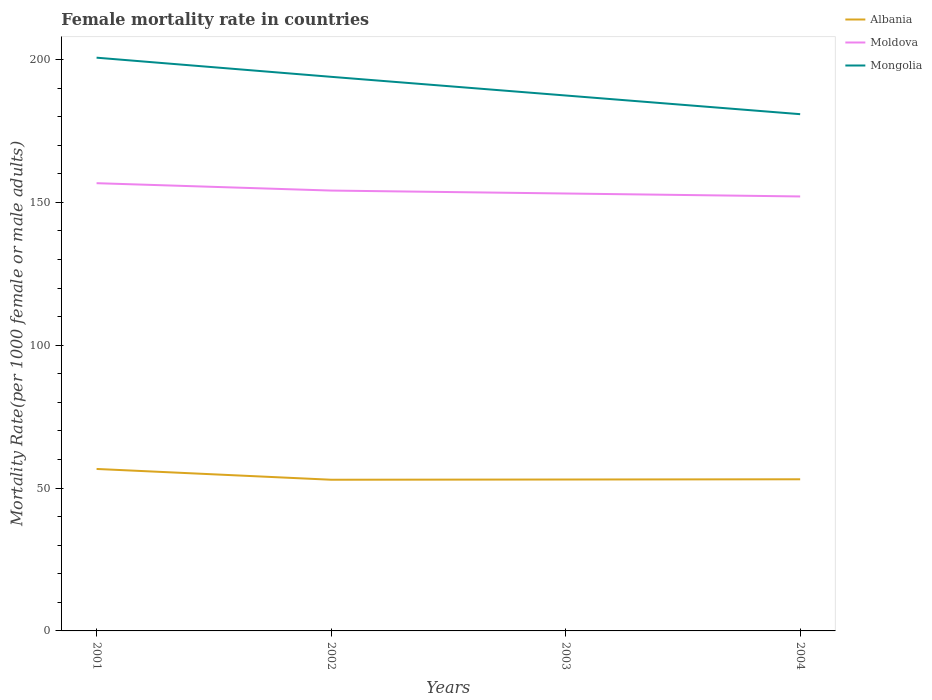How many different coloured lines are there?
Keep it short and to the point. 3. Does the line corresponding to Mongolia intersect with the line corresponding to Moldova?
Give a very brief answer. No. Is the number of lines equal to the number of legend labels?
Make the answer very short. Yes. Across all years, what is the maximum female mortality rate in Moldova?
Provide a succinct answer. 152.05. In which year was the female mortality rate in Moldova maximum?
Keep it short and to the point. 2004. What is the total female mortality rate in Mongolia in the graph?
Keep it short and to the point. 13.07. What is the difference between the highest and the second highest female mortality rate in Moldova?
Give a very brief answer. 4.64. What is the difference between the highest and the lowest female mortality rate in Moldova?
Offer a terse response. 2. How many lines are there?
Give a very brief answer. 3. How many years are there in the graph?
Offer a very short reply. 4. Does the graph contain any zero values?
Keep it short and to the point. No. What is the title of the graph?
Provide a short and direct response. Female mortality rate in countries. Does "Luxembourg" appear as one of the legend labels in the graph?
Make the answer very short. No. What is the label or title of the Y-axis?
Your answer should be compact. Mortality Rate(per 1000 female or male adults). What is the Mortality Rate(per 1000 female or male adults) of Albania in 2001?
Ensure brevity in your answer.  56.68. What is the Mortality Rate(per 1000 female or male adults) of Moldova in 2001?
Offer a very short reply. 156.69. What is the Mortality Rate(per 1000 female or male adults) of Mongolia in 2001?
Your response must be concise. 200.61. What is the Mortality Rate(per 1000 female or male adults) of Albania in 2002?
Your answer should be compact. 52.91. What is the Mortality Rate(per 1000 female or male adults) in Moldova in 2002?
Make the answer very short. 154.11. What is the Mortality Rate(per 1000 female or male adults) in Mongolia in 2002?
Ensure brevity in your answer.  193.91. What is the Mortality Rate(per 1000 female or male adults) in Albania in 2003?
Your answer should be compact. 52.99. What is the Mortality Rate(per 1000 female or male adults) in Moldova in 2003?
Your response must be concise. 153.08. What is the Mortality Rate(per 1000 female or male adults) of Mongolia in 2003?
Your response must be concise. 187.38. What is the Mortality Rate(per 1000 female or male adults) of Albania in 2004?
Make the answer very short. 53.07. What is the Mortality Rate(per 1000 female or male adults) of Moldova in 2004?
Offer a very short reply. 152.05. What is the Mortality Rate(per 1000 female or male adults) of Mongolia in 2004?
Provide a succinct answer. 180.84. Across all years, what is the maximum Mortality Rate(per 1000 female or male adults) of Albania?
Your response must be concise. 56.68. Across all years, what is the maximum Mortality Rate(per 1000 female or male adults) in Moldova?
Provide a short and direct response. 156.69. Across all years, what is the maximum Mortality Rate(per 1000 female or male adults) of Mongolia?
Make the answer very short. 200.61. Across all years, what is the minimum Mortality Rate(per 1000 female or male adults) in Albania?
Your answer should be compact. 52.91. Across all years, what is the minimum Mortality Rate(per 1000 female or male adults) in Moldova?
Give a very brief answer. 152.05. Across all years, what is the minimum Mortality Rate(per 1000 female or male adults) in Mongolia?
Offer a terse response. 180.84. What is the total Mortality Rate(per 1000 female or male adults) of Albania in the graph?
Your answer should be compact. 215.65. What is the total Mortality Rate(per 1000 female or male adults) in Moldova in the graph?
Make the answer very short. 615.93. What is the total Mortality Rate(per 1000 female or male adults) in Mongolia in the graph?
Provide a short and direct response. 762.75. What is the difference between the Mortality Rate(per 1000 female or male adults) of Albania in 2001 and that in 2002?
Your response must be concise. 3.77. What is the difference between the Mortality Rate(per 1000 female or male adults) in Moldova in 2001 and that in 2002?
Your answer should be very brief. 2.58. What is the difference between the Mortality Rate(per 1000 female or male adults) of Mongolia in 2001 and that in 2002?
Give a very brief answer. 6.7. What is the difference between the Mortality Rate(per 1000 female or male adults) of Albania in 2001 and that in 2003?
Offer a terse response. 3.7. What is the difference between the Mortality Rate(per 1000 female or male adults) of Moldova in 2001 and that in 2003?
Offer a very short reply. 3.61. What is the difference between the Mortality Rate(per 1000 female or male adults) in Mongolia in 2001 and that in 2003?
Provide a succinct answer. 13.23. What is the difference between the Mortality Rate(per 1000 female or male adults) in Albania in 2001 and that in 2004?
Offer a terse response. 3.62. What is the difference between the Mortality Rate(per 1000 female or male adults) in Moldova in 2001 and that in 2004?
Offer a terse response. 4.64. What is the difference between the Mortality Rate(per 1000 female or male adults) in Mongolia in 2001 and that in 2004?
Provide a succinct answer. 19.77. What is the difference between the Mortality Rate(per 1000 female or male adults) in Albania in 2002 and that in 2003?
Your response must be concise. -0.08. What is the difference between the Mortality Rate(per 1000 female or male adults) in Moldova in 2002 and that in 2003?
Offer a terse response. 1.03. What is the difference between the Mortality Rate(per 1000 female or male adults) of Mongolia in 2002 and that in 2003?
Provide a succinct answer. 6.54. What is the difference between the Mortality Rate(per 1000 female or male adults) in Albania in 2002 and that in 2004?
Provide a short and direct response. -0.16. What is the difference between the Mortality Rate(per 1000 female or male adults) of Moldova in 2002 and that in 2004?
Offer a very short reply. 2.06. What is the difference between the Mortality Rate(per 1000 female or male adults) of Mongolia in 2002 and that in 2004?
Make the answer very short. 13.07. What is the difference between the Mortality Rate(per 1000 female or male adults) of Albania in 2003 and that in 2004?
Give a very brief answer. -0.08. What is the difference between the Mortality Rate(per 1000 female or male adults) of Moldova in 2003 and that in 2004?
Make the answer very short. 1.03. What is the difference between the Mortality Rate(per 1000 female or male adults) in Mongolia in 2003 and that in 2004?
Provide a succinct answer. 6.54. What is the difference between the Mortality Rate(per 1000 female or male adults) of Albania in 2001 and the Mortality Rate(per 1000 female or male adults) of Moldova in 2002?
Offer a terse response. -97.43. What is the difference between the Mortality Rate(per 1000 female or male adults) in Albania in 2001 and the Mortality Rate(per 1000 female or male adults) in Mongolia in 2002?
Provide a short and direct response. -137.23. What is the difference between the Mortality Rate(per 1000 female or male adults) in Moldova in 2001 and the Mortality Rate(per 1000 female or male adults) in Mongolia in 2002?
Make the answer very short. -37.23. What is the difference between the Mortality Rate(per 1000 female or male adults) in Albania in 2001 and the Mortality Rate(per 1000 female or male adults) in Moldova in 2003?
Your answer should be very brief. -96.4. What is the difference between the Mortality Rate(per 1000 female or male adults) in Albania in 2001 and the Mortality Rate(per 1000 female or male adults) in Mongolia in 2003?
Keep it short and to the point. -130.7. What is the difference between the Mortality Rate(per 1000 female or male adults) of Moldova in 2001 and the Mortality Rate(per 1000 female or male adults) of Mongolia in 2003?
Your answer should be very brief. -30.69. What is the difference between the Mortality Rate(per 1000 female or male adults) of Albania in 2001 and the Mortality Rate(per 1000 female or male adults) of Moldova in 2004?
Your answer should be compact. -95.36. What is the difference between the Mortality Rate(per 1000 female or male adults) in Albania in 2001 and the Mortality Rate(per 1000 female or male adults) in Mongolia in 2004?
Provide a succinct answer. -124.16. What is the difference between the Mortality Rate(per 1000 female or male adults) of Moldova in 2001 and the Mortality Rate(per 1000 female or male adults) of Mongolia in 2004?
Keep it short and to the point. -24.15. What is the difference between the Mortality Rate(per 1000 female or male adults) in Albania in 2002 and the Mortality Rate(per 1000 female or male adults) in Moldova in 2003?
Offer a terse response. -100.17. What is the difference between the Mortality Rate(per 1000 female or male adults) of Albania in 2002 and the Mortality Rate(per 1000 female or male adults) of Mongolia in 2003?
Make the answer very short. -134.47. What is the difference between the Mortality Rate(per 1000 female or male adults) in Moldova in 2002 and the Mortality Rate(per 1000 female or male adults) in Mongolia in 2003?
Offer a very short reply. -33.27. What is the difference between the Mortality Rate(per 1000 female or male adults) in Albania in 2002 and the Mortality Rate(per 1000 female or male adults) in Moldova in 2004?
Your answer should be compact. -99.14. What is the difference between the Mortality Rate(per 1000 female or male adults) in Albania in 2002 and the Mortality Rate(per 1000 female or male adults) in Mongolia in 2004?
Offer a very short reply. -127.93. What is the difference between the Mortality Rate(per 1000 female or male adults) of Moldova in 2002 and the Mortality Rate(per 1000 female or male adults) of Mongolia in 2004?
Give a very brief answer. -26.73. What is the difference between the Mortality Rate(per 1000 female or male adults) in Albania in 2003 and the Mortality Rate(per 1000 female or male adults) in Moldova in 2004?
Offer a terse response. -99.06. What is the difference between the Mortality Rate(per 1000 female or male adults) in Albania in 2003 and the Mortality Rate(per 1000 female or male adults) in Mongolia in 2004?
Provide a succinct answer. -127.85. What is the difference between the Mortality Rate(per 1000 female or male adults) in Moldova in 2003 and the Mortality Rate(per 1000 female or male adults) in Mongolia in 2004?
Offer a terse response. -27.76. What is the average Mortality Rate(per 1000 female or male adults) in Albania per year?
Make the answer very short. 53.91. What is the average Mortality Rate(per 1000 female or male adults) in Moldova per year?
Offer a terse response. 153.98. What is the average Mortality Rate(per 1000 female or male adults) of Mongolia per year?
Offer a terse response. 190.69. In the year 2001, what is the difference between the Mortality Rate(per 1000 female or male adults) in Albania and Mortality Rate(per 1000 female or male adults) in Moldova?
Keep it short and to the point. -100.01. In the year 2001, what is the difference between the Mortality Rate(per 1000 female or male adults) of Albania and Mortality Rate(per 1000 female or male adults) of Mongolia?
Provide a short and direct response. -143.93. In the year 2001, what is the difference between the Mortality Rate(per 1000 female or male adults) in Moldova and Mortality Rate(per 1000 female or male adults) in Mongolia?
Make the answer very short. -43.92. In the year 2002, what is the difference between the Mortality Rate(per 1000 female or male adults) in Albania and Mortality Rate(per 1000 female or male adults) in Moldova?
Your response must be concise. -101.2. In the year 2002, what is the difference between the Mortality Rate(per 1000 female or male adults) of Albania and Mortality Rate(per 1000 female or male adults) of Mongolia?
Offer a very short reply. -141.01. In the year 2002, what is the difference between the Mortality Rate(per 1000 female or male adults) in Moldova and Mortality Rate(per 1000 female or male adults) in Mongolia?
Give a very brief answer. -39.8. In the year 2003, what is the difference between the Mortality Rate(per 1000 female or male adults) in Albania and Mortality Rate(per 1000 female or male adults) in Moldova?
Ensure brevity in your answer.  -100.09. In the year 2003, what is the difference between the Mortality Rate(per 1000 female or male adults) of Albania and Mortality Rate(per 1000 female or male adults) of Mongolia?
Give a very brief answer. -134.39. In the year 2003, what is the difference between the Mortality Rate(per 1000 female or male adults) of Moldova and Mortality Rate(per 1000 female or male adults) of Mongolia?
Provide a succinct answer. -34.3. In the year 2004, what is the difference between the Mortality Rate(per 1000 female or male adults) of Albania and Mortality Rate(per 1000 female or male adults) of Moldova?
Provide a short and direct response. -98.98. In the year 2004, what is the difference between the Mortality Rate(per 1000 female or male adults) in Albania and Mortality Rate(per 1000 female or male adults) in Mongolia?
Your answer should be compact. -127.78. In the year 2004, what is the difference between the Mortality Rate(per 1000 female or male adults) in Moldova and Mortality Rate(per 1000 female or male adults) in Mongolia?
Your answer should be compact. -28.79. What is the ratio of the Mortality Rate(per 1000 female or male adults) in Albania in 2001 to that in 2002?
Make the answer very short. 1.07. What is the ratio of the Mortality Rate(per 1000 female or male adults) of Moldova in 2001 to that in 2002?
Provide a succinct answer. 1.02. What is the ratio of the Mortality Rate(per 1000 female or male adults) in Mongolia in 2001 to that in 2002?
Ensure brevity in your answer.  1.03. What is the ratio of the Mortality Rate(per 1000 female or male adults) in Albania in 2001 to that in 2003?
Provide a succinct answer. 1.07. What is the ratio of the Mortality Rate(per 1000 female or male adults) in Moldova in 2001 to that in 2003?
Your answer should be very brief. 1.02. What is the ratio of the Mortality Rate(per 1000 female or male adults) of Mongolia in 2001 to that in 2003?
Offer a very short reply. 1.07. What is the ratio of the Mortality Rate(per 1000 female or male adults) of Albania in 2001 to that in 2004?
Keep it short and to the point. 1.07. What is the ratio of the Mortality Rate(per 1000 female or male adults) of Moldova in 2001 to that in 2004?
Your response must be concise. 1.03. What is the ratio of the Mortality Rate(per 1000 female or male adults) in Mongolia in 2001 to that in 2004?
Offer a terse response. 1.11. What is the ratio of the Mortality Rate(per 1000 female or male adults) of Moldova in 2002 to that in 2003?
Offer a terse response. 1.01. What is the ratio of the Mortality Rate(per 1000 female or male adults) of Mongolia in 2002 to that in 2003?
Your answer should be compact. 1.03. What is the ratio of the Mortality Rate(per 1000 female or male adults) in Albania in 2002 to that in 2004?
Make the answer very short. 1. What is the ratio of the Mortality Rate(per 1000 female or male adults) of Moldova in 2002 to that in 2004?
Your answer should be very brief. 1.01. What is the ratio of the Mortality Rate(per 1000 female or male adults) of Mongolia in 2002 to that in 2004?
Provide a succinct answer. 1.07. What is the ratio of the Mortality Rate(per 1000 female or male adults) in Albania in 2003 to that in 2004?
Make the answer very short. 1. What is the ratio of the Mortality Rate(per 1000 female or male adults) of Moldova in 2003 to that in 2004?
Provide a short and direct response. 1.01. What is the ratio of the Mortality Rate(per 1000 female or male adults) in Mongolia in 2003 to that in 2004?
Keep it short and to the point. 1.04. What is the difference between the highest and the second highest Mortality Rate(per 1000 female or male adults) of Albania?
Make the answer very short. 3.62. What is the difference between the highest and the second highest Mortality Rate(per 1000 female or male adults) of Moldova?
Your response must be concise. 2.58. What is the difference between the highest and the second highest Mortality Rate(per 1000 female or male adults) in Mongolia?
Offer a terse response. 6.7. What is the difference between the highest and the lowest Mortality Rate(per 1000 female or male adults) of Albania?
Ensure brevity in your answer.  3.77. What is the difference between the highest and the lowest Mortality Rate(per 1000 female or male adults) in Moldova?
Give a very brief answer. 4.64. What is the difference between the highest and the lowest Mortality Rate(per 1000 female or male adults) in Mongolia?
Provide a short and direct response. 19.77. 